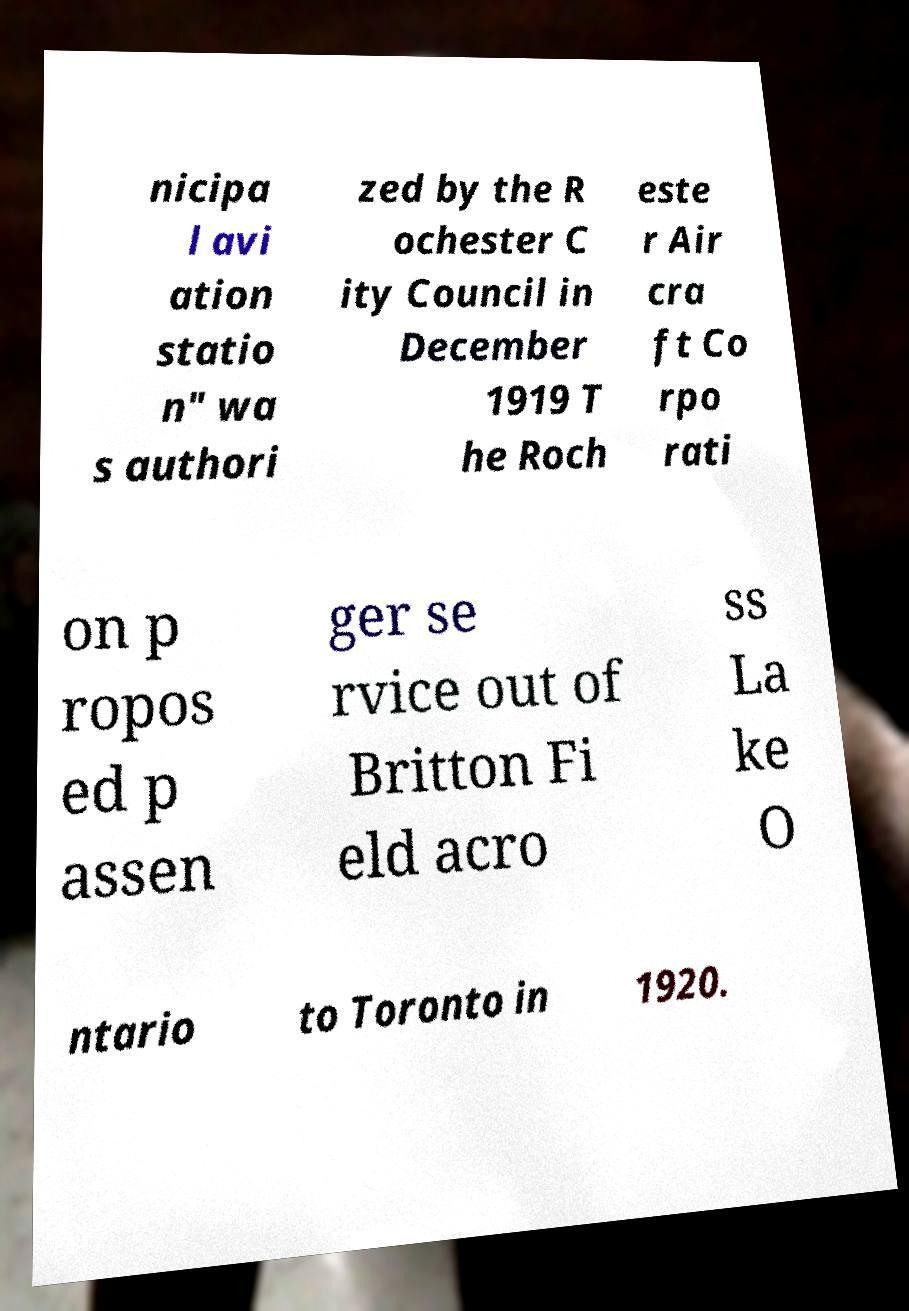Please identify and transcribe the text found in this image. nicipa l avi ation statio n" wa s authori zed by the R ochester C ity Council in December 1919 T he Roch este r Air cra ft Co rpo rati on p ropos ed p assen ger se rvice out of Britton Fi eld acro ss La ke O ntario to Toronto in 1920. 